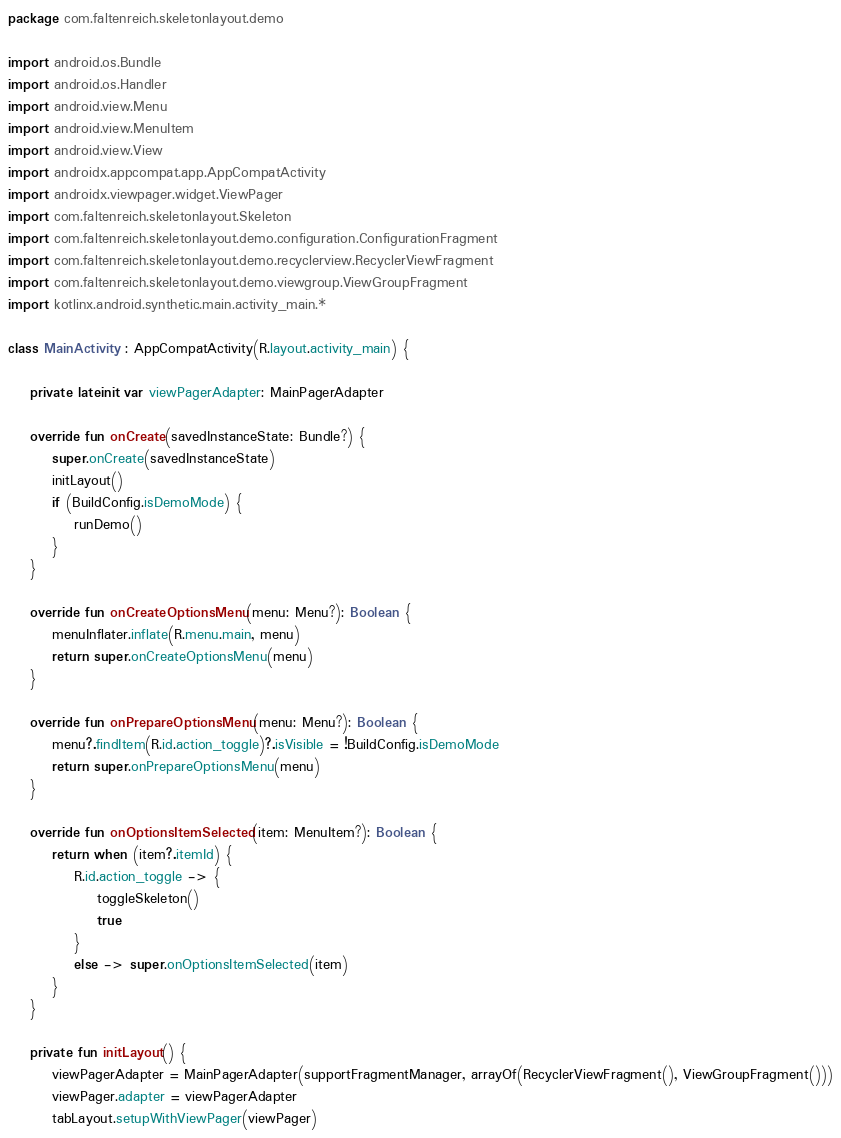Convert code to text. <code><loc_0><loc_0><loc_500><loc_500><_Kotlin_>package com.faltenreich.skeletonlayout.demo

import android.os.Bundle
import android.os.Handler
import android.view.Menu
import android.view.MenuItem
import android.view.View
import androidx.appcompat.app.AppCompatActivity
import androidx.viewpager.widget.ViewPager
import com.faltenreich.skeletonlayout.Skeleton
import com.faltenreich.skeletonlayout.demo.configuration.ConfigurationFragment
import com.faltenreich.skeletonlayout.demo.recyclerview.RecyclerViewFragment
import com.faltenreich.skeletonlayout.demo.viewgroup.ViewGroupFragment
import kotlinx.android.synthetic.main.activity_main.*

class MainActivity : AppCompatActivity(R.layout.activity_main) {

    private lateinit var viewPagerAdapter: MainPagerAdapter

    override fun onCreate(savedInstanceState: Bundle?) {
        super.onCreate(savedInstanceState)
        initLayout()
        if (BuildConfig.isDemoMode) {
            runDemo()
        }
    }

    override fun onCreateOptionsMenu(menu: Menu?): Boolean {
        menuInflater.inflate(R.menu.main, menu)
        return super.onCreateOptionsMenu(menu)
    }

    override fun onPrepareOptionsMenu(menu: Menu?): Boolean {
        menu?.findItem(R.id.action_toggle)?.isVisible = !BuildConfig.isDemoMode
        return super.onPrepareOptionsMenu(menu)
    }

    override fun onOptionsItemSelected(item: MenuItem?): Boolean {
        return when (item?.itemId) {
            R.id.action_toggle -> {
                toggleSkeleton()
                true
            }
            else -> super.onOptionsItemSelected(item)
        }
    }

    private fun initLayout() {
        viewPagerAdapter = MainPagerAdapter(supportFragmentManager, arrayOf(RecyclerViewFragment(), ViewGroupFragment()))
        viewPager.adapter = viewPagerAdapter
        tabLayout.setupWithViewPager(viewPager)
</code> 